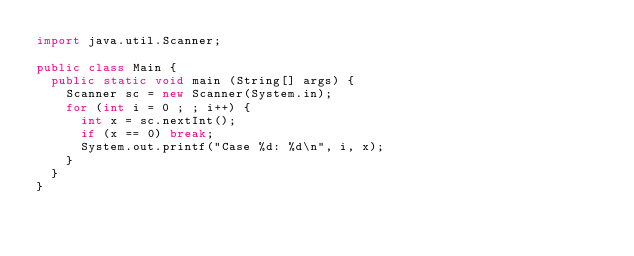<code> <loc_0><loc_0><loc_500><loc_500><_Java_>import java.util.Scanner;

public class Main {
	public static void main (String[] args) {
		Scanner sc = new Scanner(System.in);
		for (int i = 0 ; ; i++) {
			int x = sc.nextInt();
			if (x == 0) break;
			System.out.printf("Case %d: %d\n", i, x);
		}
	}
}</code> 